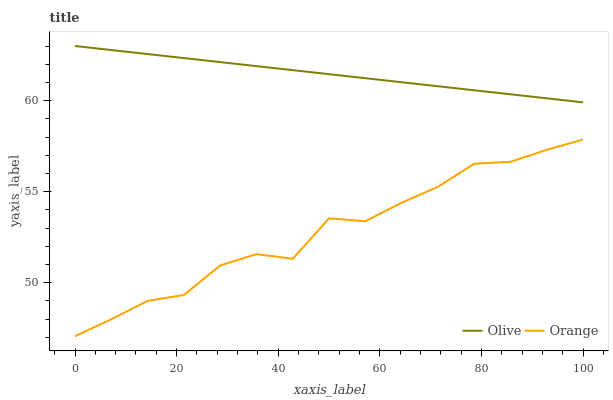Does Orange have the maximum area under the curve?
Answer yes or no. No. Is Orange the smoothest?
Answer yes or no. No. Does Orange have the highest value?
Answer yes or no. No. Is Orange less than Olive?
Answer yes or no. Yes. Is Olive greater than Orange?
Answer yes or no. Yes. Does Orange intersect Olive?
Answer yes or no. No. 